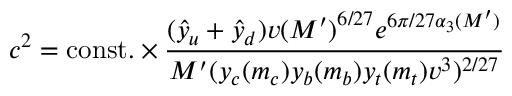<formula> <loc_0><loc_0><loc_500><loc_500>c ^ { 2 } = c o n s t . \times \frac { ( \hat { y } _ { u } + \hat { y } _ { d } ) v { ( M ^ { \prime } ) } ^ { 6 / 2 7 } e ^ { 6 \pi / 2 7 \alpha _ { 3 } ( M ^ { \prime } ) } } { M ^ { \prime } ( y _ { c } ( m _ { c } ) y _ { b } ( m _ { b } ) y _ { t } ( m _ { t } ) v ^ { 3 } ) ^ { 2 / 2 7 } }</formula> 